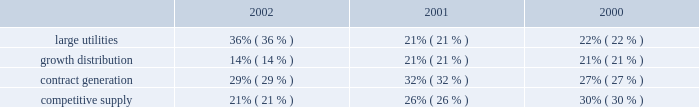Competitive supply aes 2019s competitive supply line of business consists of generating facilities that sell electricity directly to wholesale customers in competitive markets .
Additionally , as compared to the contract generation segment discussed above , these generating facilities generally sell less than 75% ( 75 % ) of their output pursuant to long-term contracts with pre-determined pricing provisions and/or sell into power pools , under shorter-term contracts or into daily spot markets .
The prices paid for electricity under short-term contracts and in the spot markets are unpredictable and can be , and from time to time have been , volatile .
The results of operations of aes 2019s competitive supply business are also more sensitive to the impact of market fluctuations in the price of electricity , natural gas , coal and other raw materials .
In the united kingdom , txu europe entered administration in november 2002 and is no longer performing under its contracts with drax and barry .
As described in the footnotes and in other sections of the discussion and analysis of financial condition and results of operations , txu europe 2019s failure to perform under its contracts has had a material adverse effect on the results of operations of these businesses .
Two aes competitive supply businesses , aes wolf hollow , l.p .
And granite ridge have fuel supply agreements with el paso merchant energy l.p .
An affiliate of el paso corp. , which has encountered financial difficulties .
The company does not believe the financial difficulties of el paso corp .
Will have a material adverse effect on el paso merchant energy l.p . 2019s performance under the supply agreement ; however , there can be no assurance that a further deterioration in el paso corp 2019s financial condition will not have a material adverse effect on the ability of el paso merchant energy l.p .
To perform its obligations .
While el paso corp 2019s financial condition may not have a material adverse effect on el paso merchant energy , l.p .
At this time , it could lead to a default under the aes wolf hollow , l.p . 2019s fuel supply agreement , in which case aes wolf hollow , l.p . 2019s lenders may seek to declare a default under its credit agreements .
Aes wolf hollow , l.p .
Is working in concert with its lenders to explore options to avoid such a default .
The revenues from our facilities that distribute electricity to end-use customers are generally subject to regulation .
These businesses are generally required to obtain third party approval or confirmation of rate increases before they can be passed on to the customers through tariffs .
These businesses comprise the large utilities and growth distribution segments of the company .
Revenues from contract generation and competitive supply are not regulated .
The distribution of revenues between the segments for the years ended december 31 , 2002 , 2001 and 2000 is as follows: .
Development costs certain subsidiaries and affiliates of the company ( domestic and non-u.s. ) are in various stages of developing and constructing greenfield power plants , some but not all of which have signed long-term contracts or made similar arrangements for the sale of electricity .
Successful completion depends upon overcoming substantial risks , including , but not limited to , risks relating to failures of siting , financing , construction , permitting , governmental approvals or the potential for termination of the power sales contract as a result of a failure to meet certain milestones .
As of december 31 , 2002 , capitalized costs for projects under development and in early stage construction were approximately $ 15 million and capitalized costs for projects under construction were approximately $ 3.2 billion .
The company believes .
What was the change in the competitive supply percentage of revenues from 2001 to 2002? 
Computations: (21% - 26%)
Answer: -0.05. Competitive supply aes 2019s competitive supply line of business consists of generating facilities that sell electricity directly to wholesale customers in competitive markets .
Additionally , as compared to the contract generation segment discussed above , these generating facilities generally sell less than 75% ( 75 % ) of their output pursuant to long-term contracts with pre-determined pricing provisions and/or sell into power pools , under shorter-term contracts or into daily spot markets .
The prices paid for electricity under short-term contracts and in the spot markets are unpredictable and can be , and from time to time have been , volatile .
The results of operations of aes 2019s competitive supply business are also more sensitive to the impact of market fluctuations in the price of electricity , natural gas , coal and other raw materials .
In the united kingdom , txu europe entered administration in november 2002 and is no longer performing under its contracts with drax and barry .
As described in the footnotes and in other sections of the discussion and analysis of financial condition and results of operations , txu europe 2019s failure to perform under its contracts has had a material adverse effect on the results of operations of these businesses .
Two aes competitive supply businesses , aes wolf hollow , l.p .
And granite ridge have fuel supply agreements with el paso merchant energy l.p .
An affiliate of el paso corp. , which has encountered financial difficulties .
The company does not believe the financial difficulties of el paso corp .
Will have a material adverse effect on el paso merchant energy l.p . 2019s performance under the supply agreement ; however , there can be no assurance that a further deterioration in el paso corp 2019s financial condition will not have a material adverse effect on the ability of el paso merchant energy l.p .
To perform its obligations .
While el paso corp 2019s financial condition may not have a material adverse effect on el paso merchant energy , l.p .
At this time , it could lead to a default under the aes wolf hollow , l.p . 2019s fuel supply agreement , in which case aes wolf hollow , l.p . 2019s lenders may seek to declare a default under its credit agreements .
Aes wolf hollow , l.p .
Is working in concert with its lenders to explore options to avoid such a default .
The revenues from our facilities that distribute electricity to end-use customers are generally subject to regulation .
These businesses are generally required to obtain third party approval or confirmation of rate increases before they can be passed on to the customers through tariffs .
These businesses comprise the large utilities and growth distribution segments of the company .
Revenues from contract generation and competitive supply are not regulated .
The distribution of revenues between the segments for the years ended december 31 , 2002 , 2001 and 2000 is as follows: .
Development costs certain subsidiaries and affiliates of the company ( domestic and non-u.s. ) are in various stages of developing and constructing greenfield power plants , some but not all of which have signed long-term contracts or made similar arrangements for the sale of electricity .
Successful completion depends upon overcoming substantial risks , including , but not limited to , risks relating to failures of siting , financing , construction , permitting , governmental approvals or the potential for termination of the power sales contract as a result of a failure to meet certain milestones .
As of december 31 , 2002 , capitalized costs for projects under development and in early stage construction were approximately $ 15 million and capitalized costs for projects under construction were approximately $ 3.2 billion .
The company believes .
For 2002 what is the range between the largest and smallest segments , based on % (  % ) of total revenue? 
Computations: (36% - 14%)
Answer: 0.22. 